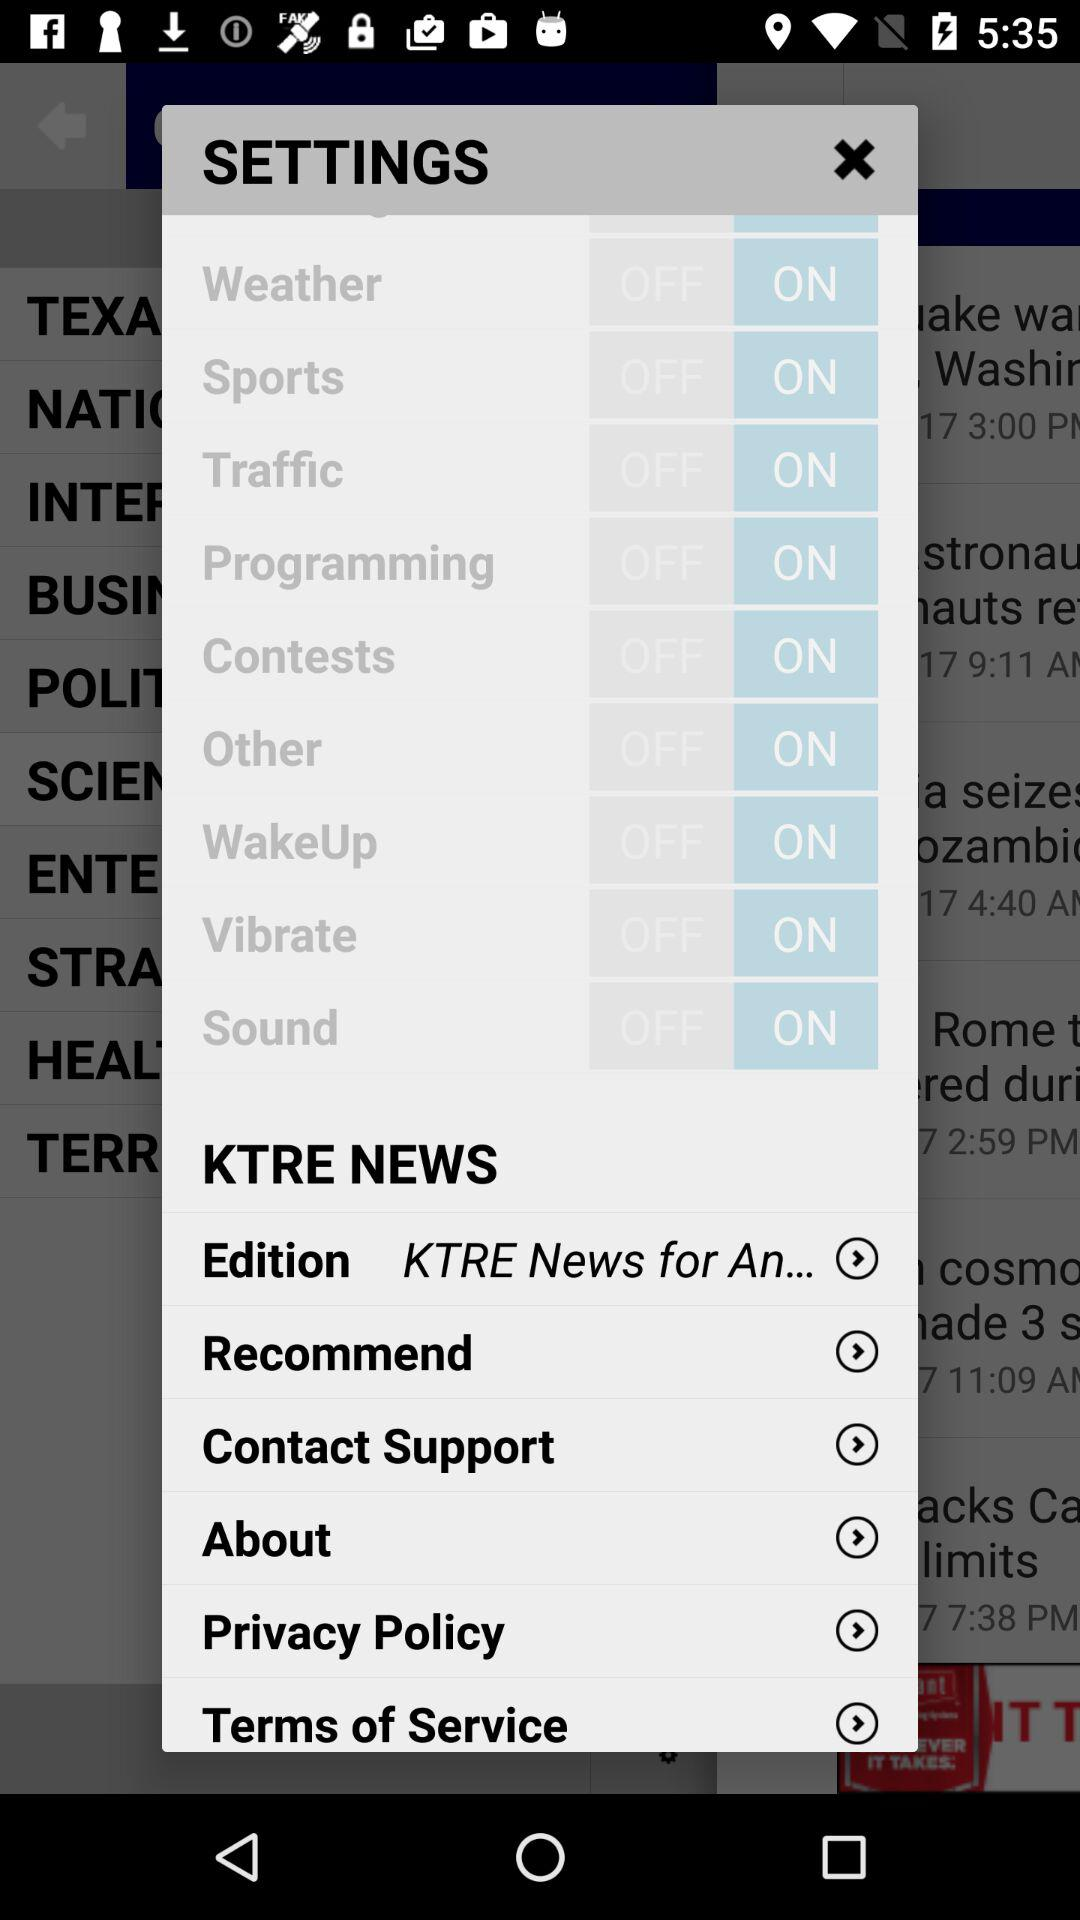What is the status of "Sound"? The status is "on". 